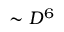Convert formula to latex. <formula><loc_0><loc_0><loc_500><loc_500>\sim D ^ { 6 }</formula> 